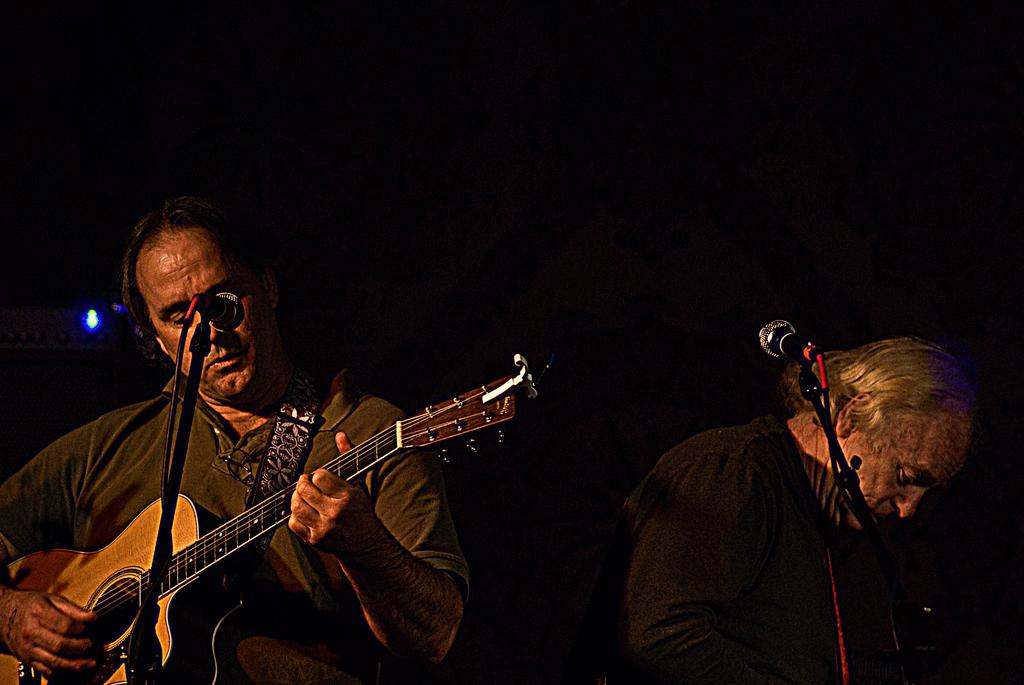How many people are in the image? There are two persons in the image. What are the persons doing in the image? Both persons are playing a guitar. Can you describe the position of one of the persons? One person is standing while playing the guitar. What object is present in the image that is commonly used for amplifying sound? There is a microphone in the image. What type of tree can be seen in the image? There is no tree present in the image. Can you describe the interaction between the two persons and a stranger in the image? There is no stranger present in the image; it only features two persons playing guitars. 